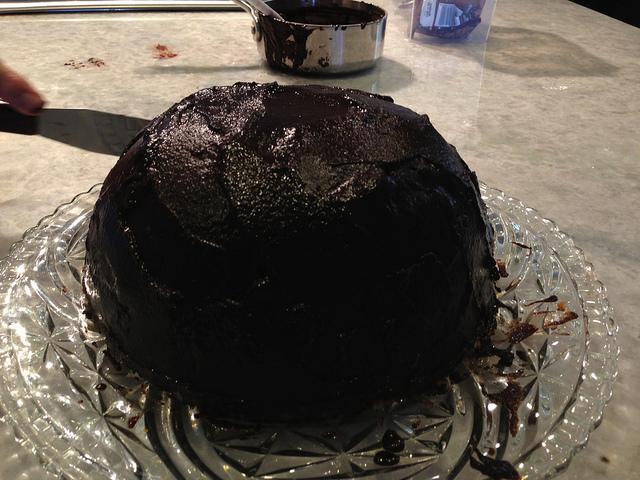Would this be served for dessert?
Give a very brief answer. Yes. What is the plate made of?
Give a very brief answer. Glass. What is the food on the plate?
Short answer required. Cake. 